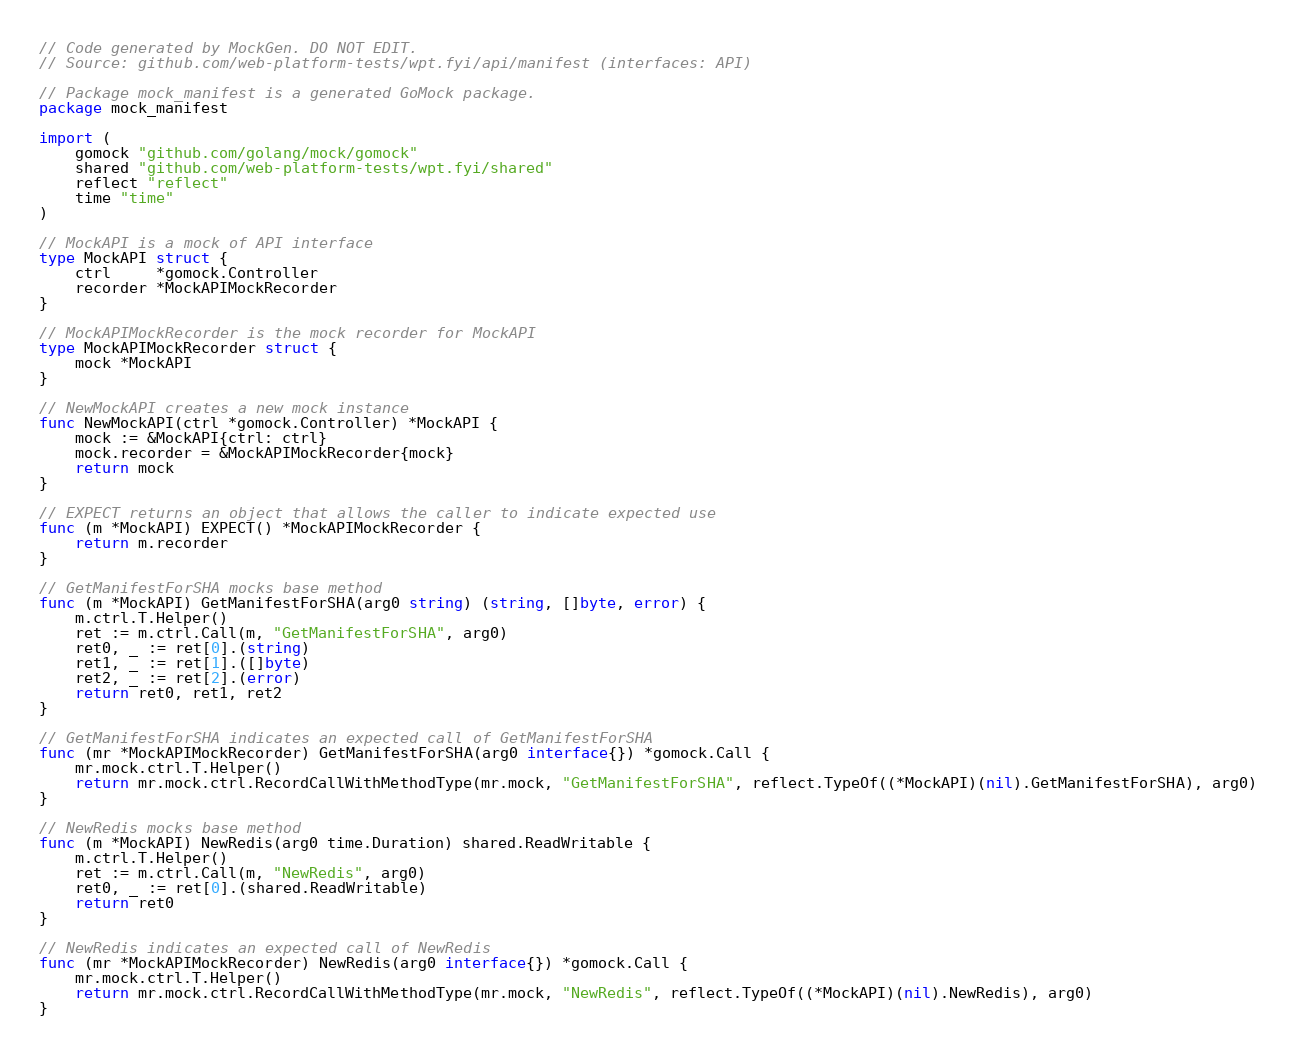<code> <loc_0><loc_0><loc_500><loc_500><_Go_>// Code generated by MockGen. DO NOT EDIT.
// Source: github.com/web-platform-tests/wpt.fyi/api/manifest (interfaces: API)

// Package mock_manifest is a generated GoMock package.
package mock_manifest

import (
	gomock "github.com/golang/mock/gomock"
	shared "github.com/web-platform-tests/wpt.fyi/shared"
	reflect "reflect"
	time "time"
)

// MockAPI is a mock of API interface
type MockAPI struct {
	ctrl     *gomock.Controller
	recorder *MockAPIMockRecorder
}

// MockAPIMockRecorder is the mock recorder for MockAPI
type MockAPIMockRecorder struct {
	mock *MockAPI
}

// NewMockAPI creates a new mock instance
func NewMockAPI(ctrl *gomock.Controller) *MockAPI {
	mock := &MockAPI{ctrl: ctrl}
	mock.recorder = &MockAPIMockRecorder{mock}
	return mock
}

// EXPECT returns an object that allows the caller to indicate expected use
func (m *MockAPI) EXPECT() *MockAPIMockRecorder {
	return m.recorder
}

// GetManifestForSHA mocks base method
func (m *MockAPI) GetManifestForSHA(arg0 string) (string, []byte, error) {
	m.ctrl.T.Helper()
	ret := m.ctrl.Call(m, "GetManifestForSHA", arg0)
	ret0, _ := ret[0].(string)
	ret1, _ := ret[1].([]byte)
	ret2, _ := ret[2].(error)
	return ret0, ret1, ret2
}

// GetManifestForSHA indicates an expected call of GetManifestForSHA
func (mr *MockAPIMockRecorder) GetManifestForSHA(arg0 interface{}) *gomock.Call {
	mr.mock.ctrl.T.Helper()
	return mr.mock.ctrl.RecordCallWithMethodType(mr.mock, "GetManifestForSHA", reflect.TypeOf((*MockAPI)(nil).GetManifestForSHA), arg0)
}

// NewRedis mocks base method
func (m *MockAPI) NewRedis(arg0 time.Duration) shared.ReadWritable {
	m.ctrl.T.Helper()
	ret := m.ctrl.Call(m, "NewRedis", arg0)
	ret0, _ := ret[0].(shared.ReadWritable)
	return ret0
}

// NewRedis indicates an expected call of NewRedis
func (mr *MockAPIMockRecorder) NewRedis(arg0 interface{}) *gomock.Call {
	mr.mock.ctrl.T.Helper()
	return mr.mock.ctrl.RecordCallWithMethodType(mr.mock, "NewRedis", reflect.TypeOf((*MockAPI)(nil).NewRedis), arg0)
}
</code> 